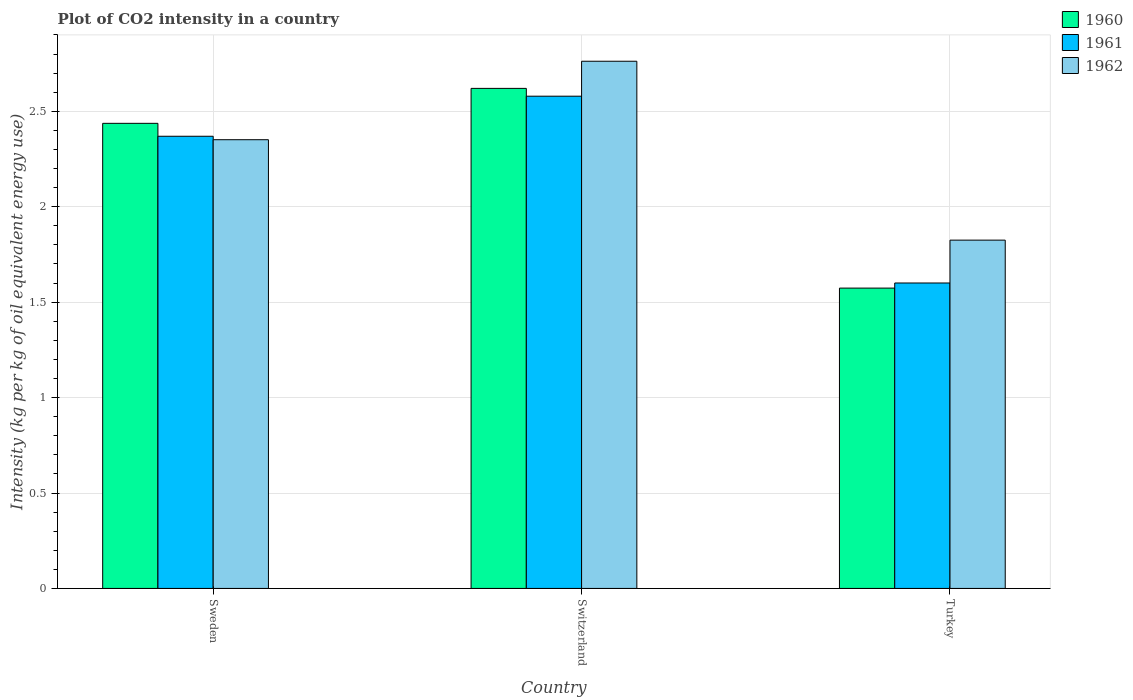How many different coloured bars are there?
Offer a very short reply. 3. Are the number of bars on each tick of the X-axis equal?
Make the answer very short. Yes. How many bars are there on the 3rd tick from the left?
Provide a short and direct response. 3. How many bars are there on the 3rd tick from the right?
Your answer should be compact. 3. In how many cases, is the number of bars for a given country not equal to the number of legend labels?
Your answer should be compact. 0. What is the CO2 intensity in in 1962 in Switzerland?
Provide a succinct answer. 2.76. Across all countries, what is the maximum CO2 intensity in in 1962?
Provide a short and direct response. 2.76. Across all countries, what is the minimum CO2 intensity in in 1961?
Offer a very short reply. 1.6. In which country was the CO2 intensity in in 1962 maximum?
Your answer should be compact. Switzerland. In which country was the CO2 intensity in in 1962 minimum?
Offer a very short reply. Turkey. What is the total CO2 intensity in in 1962 in the graph?
Make the answer very short. 6.94. What is the difference between the CO2 intensity in in 1961 in Sweden and that in Turkey?
Offer a terse response. 0.77. What is the difference between the CO2 intensity in in 1961 in Turkey and the CO2 intensity in in 1962 in Switzerland?
Keep it short and to the point. -1.16. What is the average CO2 intensity in in 1960 per country?
Ensure brevity in your answer.  2.21. What is the difference between the CO2 intensity in of/in 1962 and CO2 intensity in of/in 1960 in Sweden?
Offer a terse response. -0.09. In how many countries, is the CO2 intensity in in 1962 greater than 1.9 kg?
Make the answer very short. 2. What is the ratio of the CO2 intensity in in 1962 in Sweden to that in Turkey?
Provide a short and direct response. 1.29. Is the difference between the CO2 intensity in in 1962 in Sweden and Turkey greater than the difference between the CO2 intensity in in 1960 in Sweden and Turkey?
Your answer should be compact. No. What is the difference between the highest and the second highest CO2 intensity in in 1960?
Ensure brevity in your answer.  -1.05. What is the difference between the highest and the lowest CO2 intensity in in 1962?
Your response must be concise. 0.94. What does the 1st bar from the left in Sweden represents?
Offer a very short reply. 1960. What does the 1st bar from the right in Switzerland represents?
Ensure brevity in your answer.  1962. Is it the case that in every country, the sum of the CO2 intensity in in 1962 and CO2 intensity in in 1960 is greater than the CO2 intensity in in 1961?
Give a very brief answer. Yes. What is the difference between two consecutive major ticks on the Y-axis?
Provide a succinct answer. 0.5. Does the graph contain any zero values?
Keep it short and to the point. No. Does the graph contain grids?
Your answer should be very brief. Yes. Where does the legend appear in the graph?
Give a very brief answer. Top right. How many legend labels are there?
Provide a succinct answer. 3. How are the legend labels stacked?
Provide a succinct answer. Vertical. What is the title of the graph?
Provide a succinct answer. Plot of CO2 intensity in a country. What is the label or title of the Y-axis?
Make the answer very short. Intensity (kg per kg of oil equivalent energy use). What is the Intensity (kg per kg of oil equivalent energy use) of 1960 in Sweden?
Offer a terse response. 2.44. What is the Intensity (kg per kg of oil equivalent energy use) of 1961 in Sweden?
Provide a succinct answer. 2.37. What is the Intensity (kg per kg of oil equivalent energy use) in 1962 in Sweden?
Make the answer very short. 2.35. What is the Intensity (kg per kg of oil equivalent energy use) in 1960 in Switzerland?
Your answer should be very brief. 2.62. What is the Intensity (kg per kg of oil equivalent energy use) in 1961 in Switzerland?
Provide a succinct answer. 2.58. What is the Intensity (kg per kg of oil equivalent energy use) in 1962 in Switzerland?
Your answer should be very brief. 2.76. What is the Intensity (kg per kg of oil equivalent energy use) of 1960 in Turkey?
Offer a very short reply. 1.57. What is the Intensity (kg per kg of oil equivalent energy use) in 1961 in Turkey?
Your answer should be very brief. 1.6. What is the Intensity (kg per kg of oil equivalent energy use) in 1962 in Turkey?
Your response must be concise. 1.82. Across all countries, what is the maximum Intensity (kg per kg of oil equivalent energy use) of 1960?
Your response must be concise. 2.62. Across all countries, what is the maximum Intensity (kg per kg of oil equivalent energy use) in 1961?
Ensure brevity in your answer.  2.58. Across all countries, what is the maximum Intensity (kg per kg of oil equivalent energy use) in 1962?
Your answer should be very brief. 2.76. Across all countries, what is the minimum Intensity (kg per kg of oil equivalent energy use) in 1960?
Offer a very short reply. 1.57. Across all countries, what is the minimum Intensity (kg per kg of oil equivalent energy use) of 1961?
Offer a terse response. 1.6. Across all countries, what is the minimum Intensity (kg per kg of oil equivalent energy use) in 1962?
Provide a succinct answer. 1.82. What is the total Intensity (kg per kg of oil equivalent energy use) in 1960 in the graph?
Provide a short and direct response. 6.63. What is the total Intensity (kg per kg of oil equivalent energy use) in 1961 in the graph?
Give a very brief answer. 6.55. What is the total Intensity (kg per kg of oil equivalent energy use) in 1962 in the graph?
Your response must be concise. 6.94. What is the difference between the Intensity (kg per kg of oil equivalent energy use) in 1960 in Sweden and that in Switzerland?
Provide a succinct answer. -0.18. What is the difference between the Intensity (kg per kg of oil equivalent energy use) in 1961 in Sweden and that in Switzerland?
Provide a short and direct response. -0.21. What is the difference between the Intensity (kg per kg of oil equivalent energy use) in 1962 in Sweden and that in Switzerland?
Make the answer very short. -0.41. What is the difference between the Intensity (kg per kg of oil equivalent energy use) of 1960 in Sweden and that in Turkey?
Make the answer very short. 0.86. What is the difference between the Intensity (kg per kg of oil equivalent energy use) in 1961 in Sweden and that in Turkey?
Offer a terse response. 0.77. What is the difference between the Intensity (kg per kg of oil equivalent energy use) of 1962 in Sweden and that in Turkey?
Provide a succinct answer. 0.53. What is the difference between the Intensity (kg per kg of oil equivalent energy use) in 1960 in Switzerland and that in Turkey?
Your response must be concise. 1.05. What is the difference between the Intensity (kg per kg of oil equivalent energy use) of 1961 in Switzerland and that in Turkey?
Offer a very short reply. 0.98. What is the difference between the Intensity (kg per kg of oil equivalent energy use) of 1962 in Switzerland and that in Turkey?
Your response must be concise. 0.94. What is the difference between the Intensity (kg per kg of oil equivalent energy use) of 1960 in Sweden and the Intensity (kg per kg of oil equivalent energy use) of 1961 in Switzerland?
Offer a very short reply. -0.14. What is the difference between the Intensity (kg per kg of oil equivalent energy use) in 1960 in Sweden and the Intensity (kg per kg of oil equivalent energy use) in 1962 in Switzerland?
Ensure brevity in your answer.  -0.33. What is the difference between the Intensity (kg per kg of oil equivalent energy use) in 1961 in Sweden and the Intensity (kg per kg of oil equivalent energy use) in 1962 in Switzerland?
Your answer should be compact. -0.39. What is the difference between the Intensity (kg per kg of oil equivalent energy use) in 1960 in Sweden and the Intensity (kg per kg of oil equivalent energy use) in 1961 in Turkey?
Give a very brief answer. 0.84. What is the difference between the Intensity (kg per kg of oil equivalent energy use) in 1960 in Sweden and the Intensity (kg per kg of oil equivalent energy use) in 1962 in Turkey?
Give a very brief answer. 0.61. What is the difference between the Intensity (kg per kg of oil equivalent energy use) of 1961 in Sweden and the Intensity (kg per kg of oil equivalent energy use) of 1962 in Turkey?
Your answer should be compact. 0.54. What is the difference between the Intensity (kg per kg of oil equivalent energy use) in 1960 in Switzerland and the Intensity (kg per kg of oil equivalent energy use) in 1961 in Turkey?
Keep it short and to the point. 1.02. What is the difference between the Intensity (kg per kg of oil equivalent energy use) in 1960 in Switzerland and the Intensity (kg per kg of oil equivalent energy use) in 1962 in Turkey?
Make the answer very short. 0.8. What is the difference between the Intensity (kg per kg of oil equivalent energy use) in 1961 in Switzerland and the Intensity (kg per kg of oil equivalent energy use) in 1962 in Turkey?
Your response must be concise. 0.75. What is the average Intensity (kg per kg of oil equivalent energy use) of 1960 per country?
Give a very brief answer. 2.21. What is the average Intensity (kg per kg of oil equivalent energy use) of 1961 per country?
Ensure brevity in your answer.  2.18. What is the average Intensity (kg per kg of oil equivalent energy use) of 1962 per country?
Offer a very short reply. 2.31. What is the difference between the Intensity (kg per kg of oil equivalent energy use) in 1960 and Intensity (kg per kg of oil equivalent energy use) in 1961 in Sweden?
Provide a short and direct response. 0.07. What is the difference between the Intensity (kg per kg of oil equivalent energy use) in 1960 and Intensity (kg per kg of oil equivalent energy use) in 1962 in Sweden?
Offer a terse response. 0.09. What is the difference between the Intensity (kg per kg of oil equivalent energy use) of 1961 and Intensity (kg per kg of oil equivalent energy use) of 1962 in Sweden?
Your response must be concise. 0.02. What is the difference between the Intensity (kg per kg of oil equivalent energy use) in 1960 and Intensity (kg per kg of oil equivalent energy use) in 1961 in Switzerland?
Ensure brevity in your answer.  0.04. What is the difference between the Intensity (kg per kg of oil equivalent energy use) of 1960 and Intensity (kg per kg of oil equivalent energy use) of 1962 in Switzerland?
Offer a very short reply. -0.14. What is the difference between the Intensity (kg per kg of oil equivalent energy use) in 1961 and Intensity (kg per kg of oil equivalent energy use) in 1962 in Switzerland?
Your answer should be compact. -0.18. What is the difference between the Intensity (kg per kg of oil equivalent energy use) in 1960 and Intensity (kg per kg of oil equivalent energy use) in 1961 in Turkey?
Keep it short and to the point. -0.03. What is the difference between the Intensity (kg per kg of oil equivalent energy use) in 1960 and Intensity (kg per kg of oil equivalent energy use) in 1962 in Turkey?
Your answer should be very brief. -0.25. What is the difference between the Intensity (kg per kg of oil equivalent energy use) of 1961 and Intensity (kg per kg of oil equivalent energy use) of 1962 in Turkey?
Keep it short and to the point. -0.22. What is the ratio of the Intensity (kg per kg of oil equivalent energy use) in 1960 in Sweden to that in Switzerland?
Ensure brevity in your answer.  0.93. What is the ratio of the Intensity (kg per kg of oil equivalent energy use) in 1961 in Sweden to that in Switzerland?
Keep it short and to the point. 0.92. What is the ratio of the Intensity (kg per kg of oil equivalent energy use) of 1962 in Sweden to that in Switzerland?
Your response must be concise. 0.85. What is the ratio of the Intensity (kg per kg of oil equivalent energy use) of 1960 in Sweden to that in Turkey?
Ensure brevity in your answer.  1.55. What is the ratio of the Intensity (kg per kg of oil equivalent energy use) of 1961 in Sweden to that in Turkey?
Your answer should be very brief. 1.48. What is the ratio of the Intensity (kg per kg of oil equivalent energy use) of 1962 in Sweden to that in Turkey?
Your answer should be very brief. 1.29. What is the ratio of the Intensity (kg per kg of oil equivalent energy use) in 1960 in Switzerland to that in Turkey?
Your answer should be compact. 1.67. What is the ratio of the Intensity (kg per kg of oil equivalent energy use) in 1961 in Switzerland to that in Turkey?
Offer a very short reply. 1.61. What is the ratio of the Intensity (kg per kg of oil equivalent energy use) of 1962 in Switzerland to that in Turkey?
Make the answer very short. 1.51. What is the difference between the highest and the second highest Intensity (kg per kg of oil equivalent energy use) of 1960?
Your response must be concise. 0.18. What is the difference between the highest and the second highest Intensity (kg per kg of oil equivalent energy use) in 1961?
Ensure brevity in your answer.  0.21. What is the difference between the highest and the second highest Intensity (kg per kg of oil equivalent energy use) in 1962?
Your answer should be compact. 0.41. What is the difference between the highest and the lowest Intensity (kg per kg of oil equivalent energy use) of 1960?
Offer a very short reply. 1.05. What is the difference between the highest and the lowest Intensity (kg per kg of oil equivalent energy use) in 1961?
Your answer should be compact. 0.98. What is the difference between the highest and the lowest Intensity (kg per kg of oil equivalent energy use) of 1962?
Ensure brevity in your answer.  0.94. 